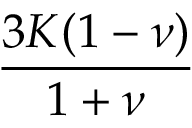Convert formula to latex. <formula><loc_0><loc_0><loc_500><loc_500>\frac { 3 K ( 1 - \nu ) } { 1 + \nu }</formula> 